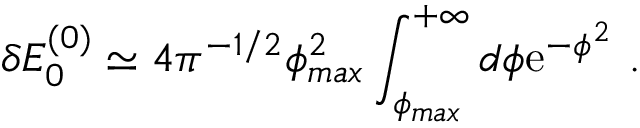Convert formula to latex. <formula><loc_0><loc_0><loc_500><loc_500>\delta E _ { 0 } ^ { ( 0 ) } \simeq 4 \pi ^ { - 1 / 2 } \phi _ { \max } ^ { 2 } \int _ { \phi _ { \max } } ^ { + \infty } d \phi e ^ { - \phi ^ { 2 } } \ .</formula> 